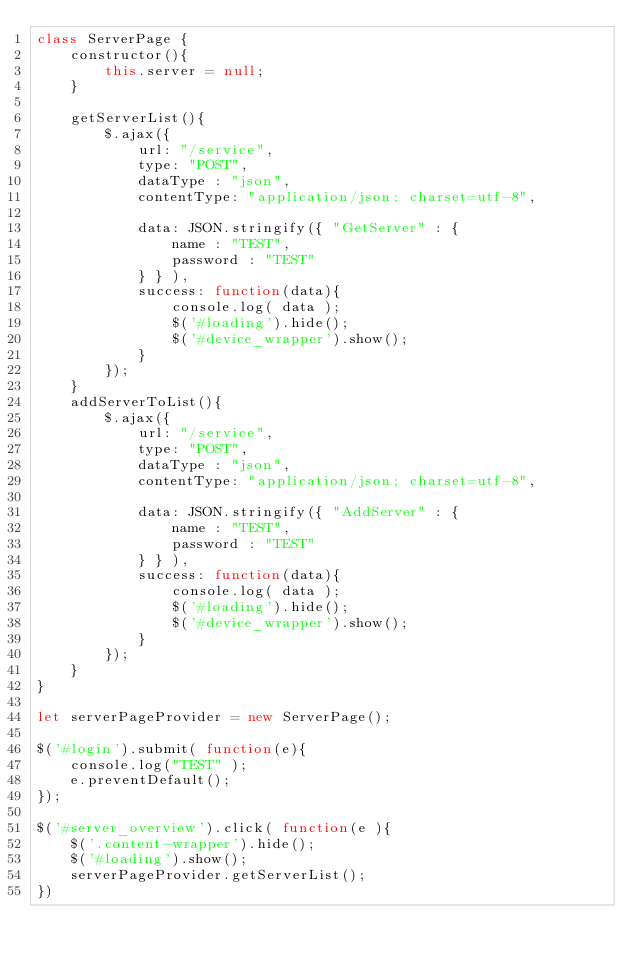<code> <loc_0><loc_0><loc_500><loc_500><_JavaScript_>class ServerPage {
    constructor(){
        this.server = null;
    }

    getServerList(){
        $.ajax({
            url: "/service",
            type: "POST",
            dataType : "json",
            contentType: "application/json; charset=utf-8",
            
            data: JSON.stringify({ "GetServer" : {
                name : "TEST",
                password : "TEST" 
            } } ),
            success: function(data){
                console.log( data );
                $('#loading').hide();
                $('#device_wrapper').show();
            }
        }); 
    }
    addServerToList(){
        $.ajax({
            url: "/service",
            type: "POST",
            dataType : "json",
            contentType: "application/json; charset=utf-8",
            
            data: JSON.stringify({ "AddServer" : {
                name : "TEST",
                password : "TEST" 
            } } ),
            success: function(data){
                console.log( data );
                $('#loading').hide();
                $('#device_wrapper').show();
            }
        }); 
    }
}

let serverPageProvider = new ServerPage();

$('#login').submit( function(e){
    console.log("TEST" );
    e.preventDefault();
});

$('#server_overview').click( function(e ){
    $('.content-wrapper').hide();
    $('#loading').show();
    serverPageProvider.getServerList();
})


</code> 